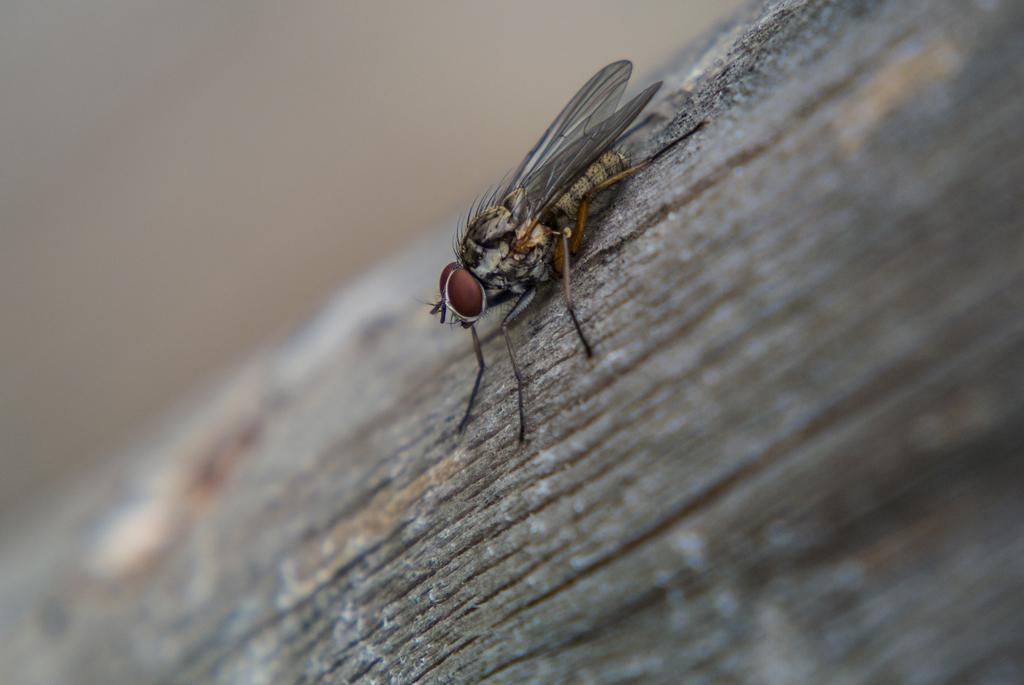What type of insect is present in the image? There is a house fly in the picture. Can you describe the background of the image? The background of the image is blurry. How many rings are being worn by the secretary in the image? There is no secretary or rings present in the image; it only features a house fly. Is there a fight happening in the image? There is no fight depicted in the image; it only features a house fly. 